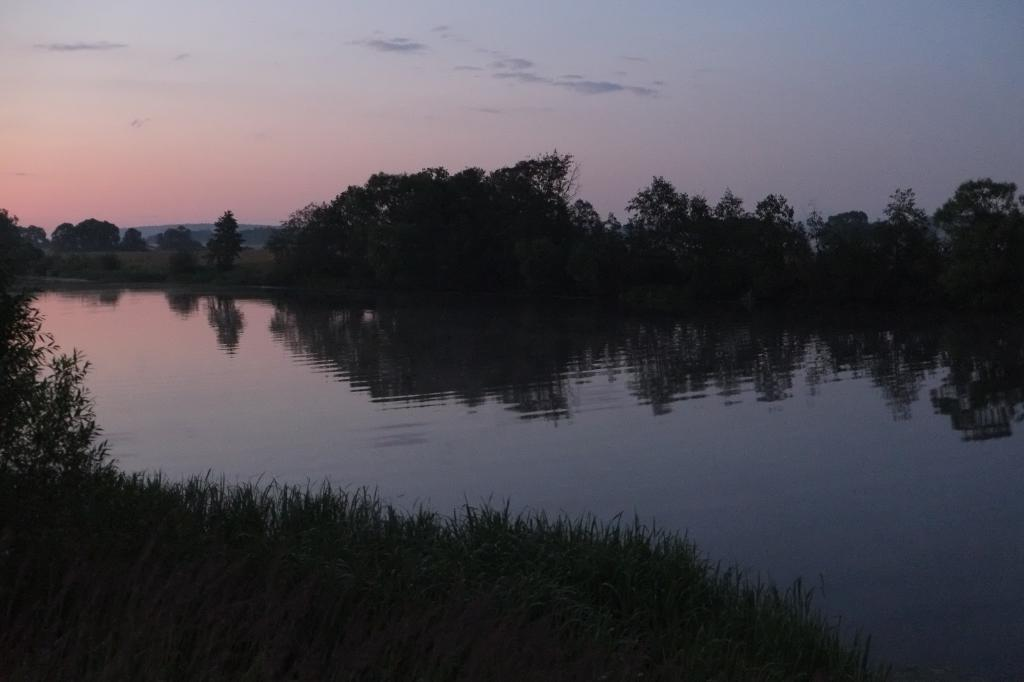What is located in the middle of the image? There is water in the middle of the image. What type of vegetation is on either side of the water? There are trees on either side of the water. What can be seen in the background of the image? The sky is visible in the background of the image. Where is the bean located in the image? There is no bean present in the image. Is there a chair visible in the image? There is no chair visible in the image. 